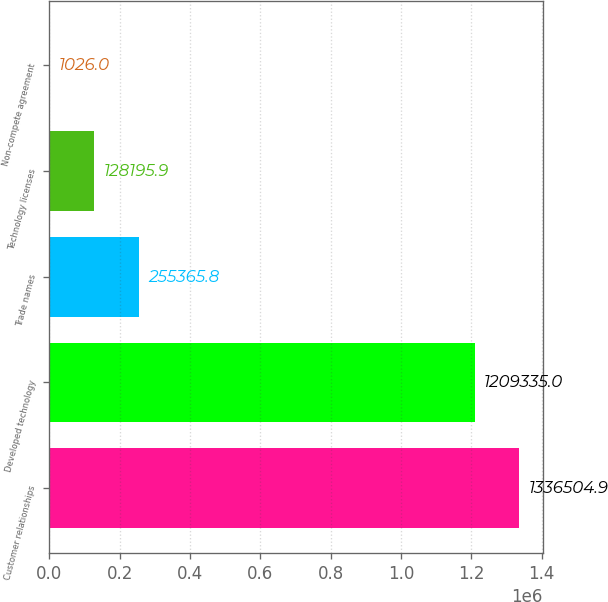Convert chart. <chart><loc_0><loc_0><loc_500><loc_500><bar_chart><fcel>Customer relationships<fcel>Developed technology<fcel>Trade names<fcel>Technology licenses<fcel>Non-compete agreement<nl><fcel>1.3365e+06<fcel>1.20934e+06<fcel>255366<fcel>128196<fcel>1026<nl></chart> 